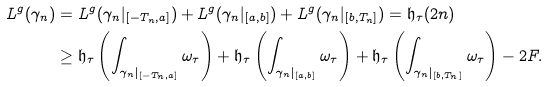<formula> <loc_0><loc_0><loc_500><loc_500>L ^ { g } ( \gamma _ { n } ) & = L ^ { g } ( \gamma _ { n } | _ { [ - T _ { n } , a ] } ) + L ^ { g } ( \gamma _ { n } | _ { [ a , b ] } ) + L ^ { g } ( \gamma _ { n } | _ { [ b , T _ { n } ] } ) = \mathfrak { h } _ { \tau } ( 2 n ) \\ & \geq \mathfrak { h } _ { \tau } \left ( \int _ { \gamma _ { n } | _ { [ - T _ { n } , a ] } } \omega _ { \tau } \right ) + \mathfrak { h } _ { \tau } \left ( \int _ { \gamma _ { n } | _ { [ a , b ] } } \omega _ { \tau } \right ) + \mathfrak { h } _ { \tau } \left ( \int _ { \gamma _ { n } | _ { [ b , T _ { n } ] } } \omega _ { \tau } \right ) - 2 F .</formula> 